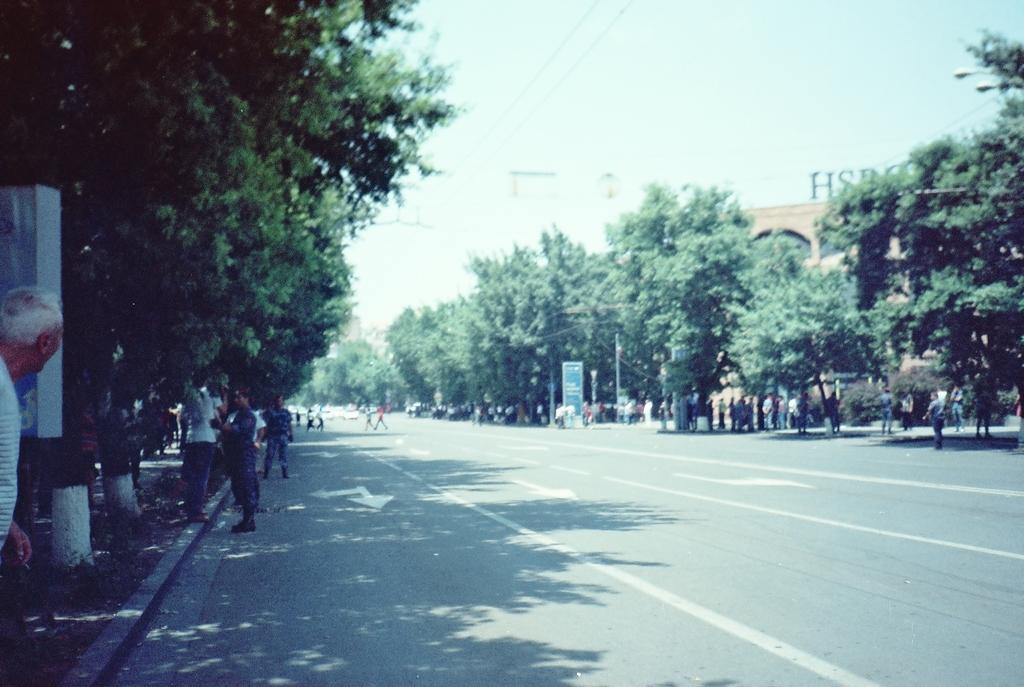What can be seen beside the road in the image? There are trees beside the road in the image. What are the groups of people doing in the image? The groups of people are standing in the image. What is the purpose of the board visible in the image? The purpose of the board is not specified, but it is visible in the image. What type of pathway is present in the image? There is a road in the image. What is the name of the building in the image? The building with a name board on it has a name, but it cannot be determined from the image alone. How much money is being exchanged between the groups of people in the image? There is no indication of any money exchange in the image; people are simply standing. Can you touch the trees beside the road in the image? You cannot touch the trees in the image, as it is a two-dimensional representation. 